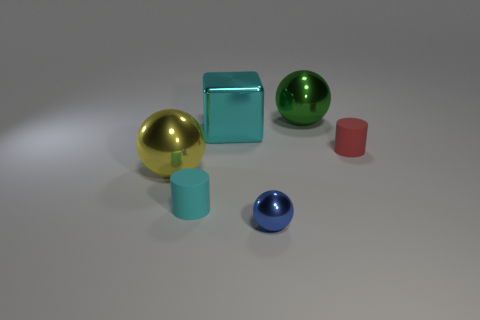Subtract all blue balls. How many balls are left? 2 Subtract all big metallic spheres. How many spheres are left? 1 Subtract 0 gray cylinders. How many objects are left? 6 Subtract all cylinders. How many objects are left? 4 Subtract 1 cylinders. How many cylinders are left? 1 Subtract all red blocks. Subtract all cyan balls. How many blocks are left? 1 Subtract all yellow balls. How many brown cylinders are left? 0 Subtract all yellow shiny objects. Subtract all red rubber cylinders. How many objects are left? 4 Add 6 small cylinders. How many small cylinders are left? 8 Add 5 cyan spheres. How many cyan spheres exist? 5 